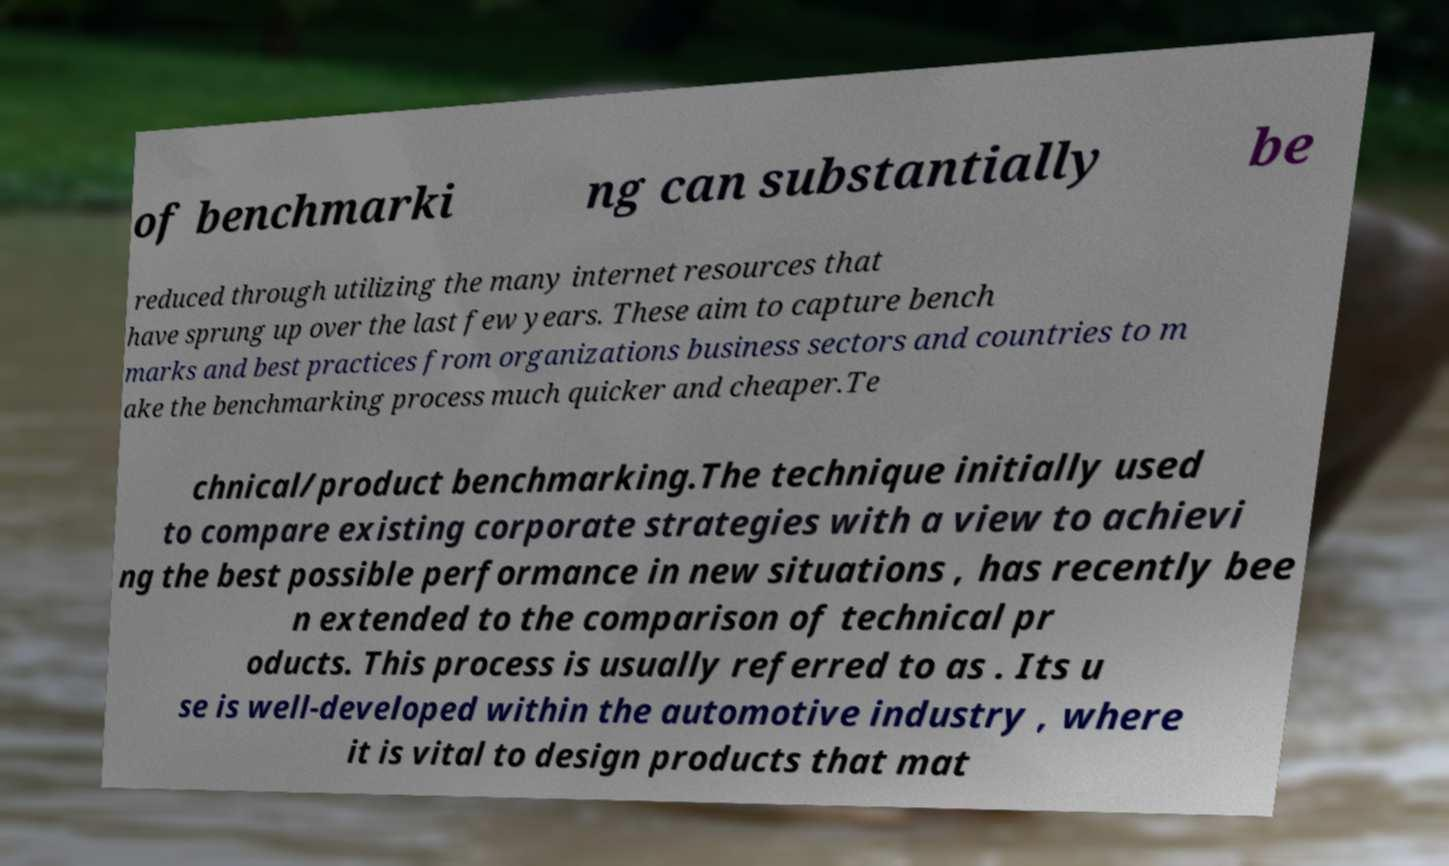For documentation purposes, I need the text within this image transcribed. Could you provide that? of benchmarki ng can substantially be reduced through utilizing the many internet resources that have sprung up over the last few years. These aim to capture bench marks and best practices from organizations business sectors and countries to m ake the benchmarking process much quicker and cheaper.Te chnical/product benchmarking.The technique initially used to compare existing corporate strategies with a view to achievi ng the best possible performance in new situations , has recently bee n extended to the comparison of technical pr oducts. This process is usually referred to as . Its u se is well-developed within the automotive industry , where it is vital to design products that mat 